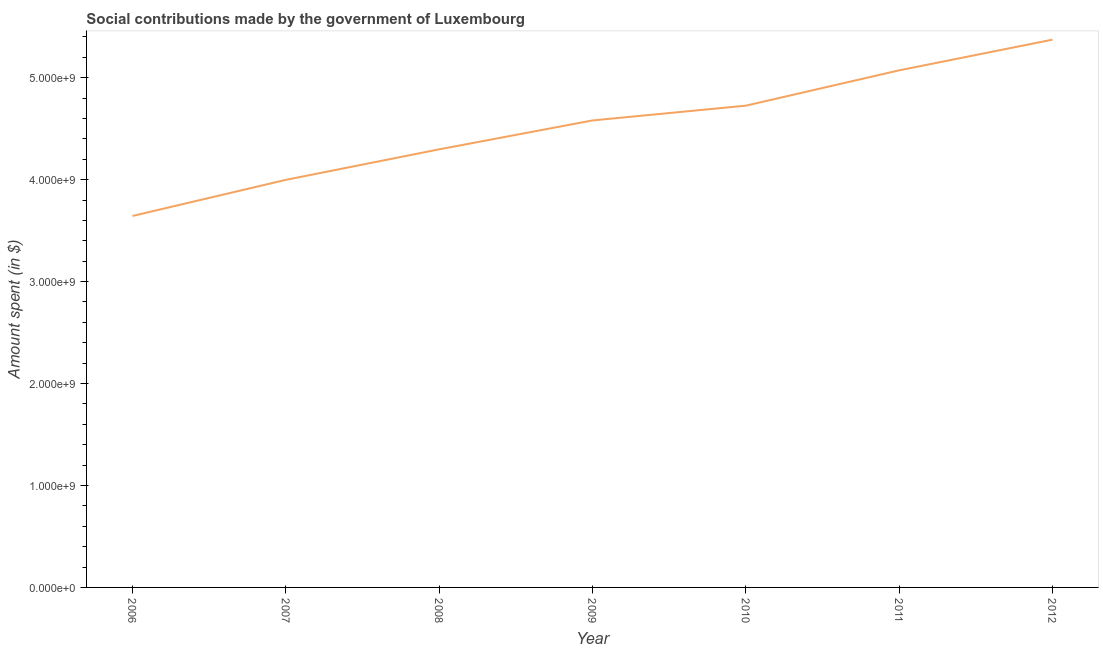What is the amount spent in making social contributions in 2011?
Make the answer very short. 5.07e+09. Across all years, what is the maximum amount spent in making social contributions?
Offer a very short reply. 5.37e+09. Across all years, what is the minimum amount spent in making social contributions?
Your response must be concise. 3.64e+09. What is the sum of the amount spent in making social contributions?
Provide a short and direct response. 3.17e+1. What is the difference between the amount spent in making social contributions in 2010 and 2012?
Your response must be concise. -6.48e+08. What is the average amount spent in making social contributions per year?
Ensure brevity in your answer.  4.53e+09. What is the median amount spent in making social contributions?
Provide a short and direct response. 4.58e+09. What is the ratio of the amount spent in making social contributions in 2007 to that in 2010?
Your response must be concise. 0.85. Is the difference between the amount spent in making social contributions in 2008 and 2011 greater than the difference between any two years?
Provide a succinct answer. No. What is the difference between the highest and the second highest amount spent in making social contributions?
Make the answer very short. 3.01e+08. What is the difference between the highest and the lowest amount spent in making social contributions?
Provide a succinct answer. 1.73e+09. In how many years, is the amount spent in making social contributions greater than the average amount spent in making social contributions taken over all years?
Offer a terse response. 4. Does the amount spent in making social contributions monotonically increase over the years?
Offer a terse response. Yes. How many years are there in the graph?
Keep it short and to the point. 7. What is the difference between two consecutive major ticks on the Y-axis?
Ensure brevity in your answer.  1.00e+09. Are the values on the major ticks of Y-axis written in scientific E-notation?
Offer a very short reply. Yes. Does the graph contain grids?
Give a very brief answer. No. What is the title of the graph?
Give a very brief answer. Social contributions made by the government of Luxembourg. What is the label or title of the X-axis?
Provide a short and direct response. Year. What is the label or title of the Y-axis?
Provide a succinct answer. Amount spent (in $). What is the Amount spent (in $) in 2006?
Your answer should be compact. 3.64e+09. What is the Amount spent (in $) in 2007?
Provide a short and direct response. 4.00e+09. What is the Amount spent (in $) in 2008?
Provide a succinct answer. 4.30e+09. What is the Amount spent (in $) in 2009?
Make the answer very short. 4.58e+09. What is the Amount spent (in $) in 2010?
Your answer should be compact. 4.73e+09. What is the Amount spent (in $) of 2011?
Provide a short and direct response. 5.07e+09. What is the Amount spent (in $) in 2012?
Make the answer very short. 5.37e+09. What is the difference between the Amount spent (in $) in 2006 and 2007?
Your response must be concise. -3.54e+08. What is the difference between the Amount spent (in $) in 2006 and 2008?
Your response must be concise. -6.53e+08. What is the difference between the Amount spent (in $) in 2006 and 2009?
Make the answer very short. -9.37e+08. What is the difference between the Amount spent (in $) in 2006 and 2010?
Ensure brevity in your answer.  -1.08e+09. What is the difference between the Amount spent (in $) in 2006 and 2011?
Your response must be concise. -1.43e+09. What is the difference between the Amount spent (in $) in 2006 and 2012?
Offer a terse response. -1.73e+09. What is the difference between the Amount spent (in $) in 2007 and 2008?
Offer a terse response. -2.99e+08. What is the difference between the Amount spent (in $) in 2007 and 2009?
Your response must be concise. -5.83e+08. What is the difference between the Amount spent (in $) in 2007 and 2010?
Offer a terse response. -7.28e+08. What is the difference between the Amount spent (in $) in 2007 and 2011?
Your answer should be very brief. -1.07e+09. What is the difference between the Amount spent (in $) in 2007 and 2012?
Offer a very short reply. -1.38e+09. What is the difference between the Amount spent (in $) in 2008 and 2009?
Make the answer very short. -2.83e+08. What is the difference between the Amount spent (in $) in 2008 and 2010?
Ensure brevity in your answer.  -4.28e+08. What is the difference between the Amount spent (in $) in 2008 and 2011?
Your response must be concise. -7.75e+08. What is the difference between the Amount spent (in $) in 2008 and 2012?
Make the answer very short. -1.08e+09. What is the difference between the Amount spent (in $) in 2009 and 2010?
Keep it short and to the point. -1.45e+08. What is the difference between the Amount spent (in $) in 2009 and 2011?
Offer a terse response. -4.92e+08. What is the difference between the Amount spent (in $) in 2009 and 2012?
Make the answer very short. -7.93e+08. What is the difference between the Amount spent (in $) in 2010 and 2011?
Offer a terse response. -3.47e+08. What is the difference between the Amount spent (in $) in 2010 and 2012?
Provide a succinct answer. -6.48e+08. What is the difference between the Amount spent (in $) in 2011 and 2012?
Your answer should be compact. -3.01e+08. What is the ratio of the Amount spent (in $) in 2006 to that in 2007?
Your answer should be compact. 0.91. What is the ratio of the Amount spent (in $) in 2006 to that in 2008?
Offer a very short reply. 0.85. What is the ratio of the Amount spent (in $) in 2006 to that in 2009?
Keep it short and to the point. 0.8. What is the ratio of the Amount spent (in $) in 2006 to that in 2010?
Offer a terse response. 0.77. What is the ratio of the Amount spent (in $) in 2006 to that in 2011?
Provide a short and direct response. 0.72. What is the ratio of the Amount spent (in $) in 2006 to that in 2012?
Offer a terse response. 0.68. What is the ratio of the Amount spent (in $) in 2007 to that in 2008?
Your answer should be very brief. 0.93. What is the ratio of the Amount spent (in $) in 2007 to that in 2009?
Keep it short and to the point. 0.87. What is the ratio of the Amount spent (in $) in 2007 to that in 2010?
Offer a very short reply. 0.85. What is the ratio of the Amount spent (in $) in 2007 to that in 2011?
Your answer should be compact. 0.79. What is the ratio of the Amount spent (in $) in 2007 to that in 2012?
Keep it short and to the point. 0.74. What is the ratio of the Amount spent (in $) in 2008 to that in 2009?
Provide a succinct answer. 0.94. What is the ratio of the Amount spent (in $) in 2008 to that in 2010?
Your answer should be compact. 0.91. What is the ratio of the Amount spent (in $) in 2008 to that in 2011?
Your response must be concise. 0.85. What is the ratio of the Amount spent (in $) in 2009 to that in 2010?
Offer a terse response. 0.97. What is the ratio of the Amount spent (in $) in 2009 to that in 2011?
Keep it short and to the point. 0.9. What is the ratio of the Amount spent (in $) in 2009 to that in 2012?
Keep it short and to the point. 0.85. What is the ratio of the Amount spent (in $) in 2010 to that in 2011?
Offer a terse response. 0.93. What is the ratio of the Amount spent (in $) in 2010 to that in 2012?
Make the answer very short. 0.88. What is the ratio of the Amount spent (in $) in 2011 to that in 2012?
Make the answer very short. 0.94. 